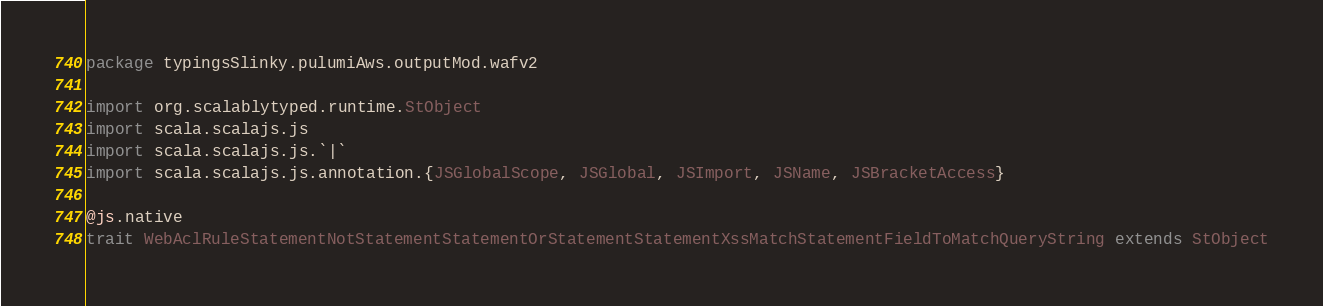<code> <loc_0><loc_0><loc_500><loc_500><_Scala_>package typingsSlinky.pulumiAws.outputMod.wafv2

import org.scalablytyped.runtime.StObject
import scala.scalajs.js
import scala.scalajs.js.`|`
import scala.scalajs.js.annotation.{JSGlobalScope, JSGlobal, JSImport, JSName, JSBracketAccess}

@js.native
trait WebAclRuleStatementNotStatementStatementOrStatementStatementXssMatchStatementFieldToMatchQueryString extends StObject
</code> 